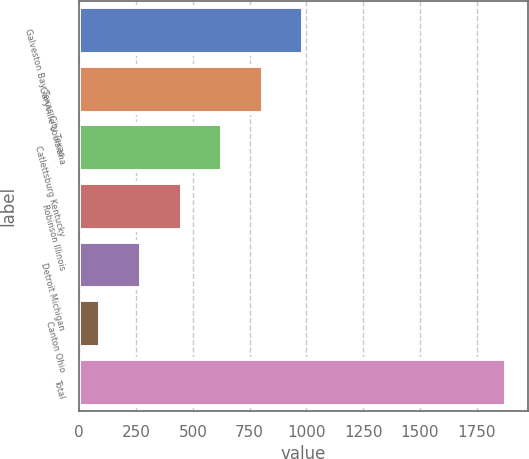<chart> <loc_0><loc_0><loc_500><loc_500><bar_chart><fcel>Galveston Bay Texas City Texas<fcel>Garyville Louisiana<fcel>Catlettsburg Kentucky<fcel>Robinson Illinois<fcel>Detroit Michigan<fcel>Canton Ohio<fcel>Total<nl><fcel>987<fcel>808.2<fcel>629.4<fcel>450.6<fcel>271.8<fcel>93<fcel>1881<nl></chart> 